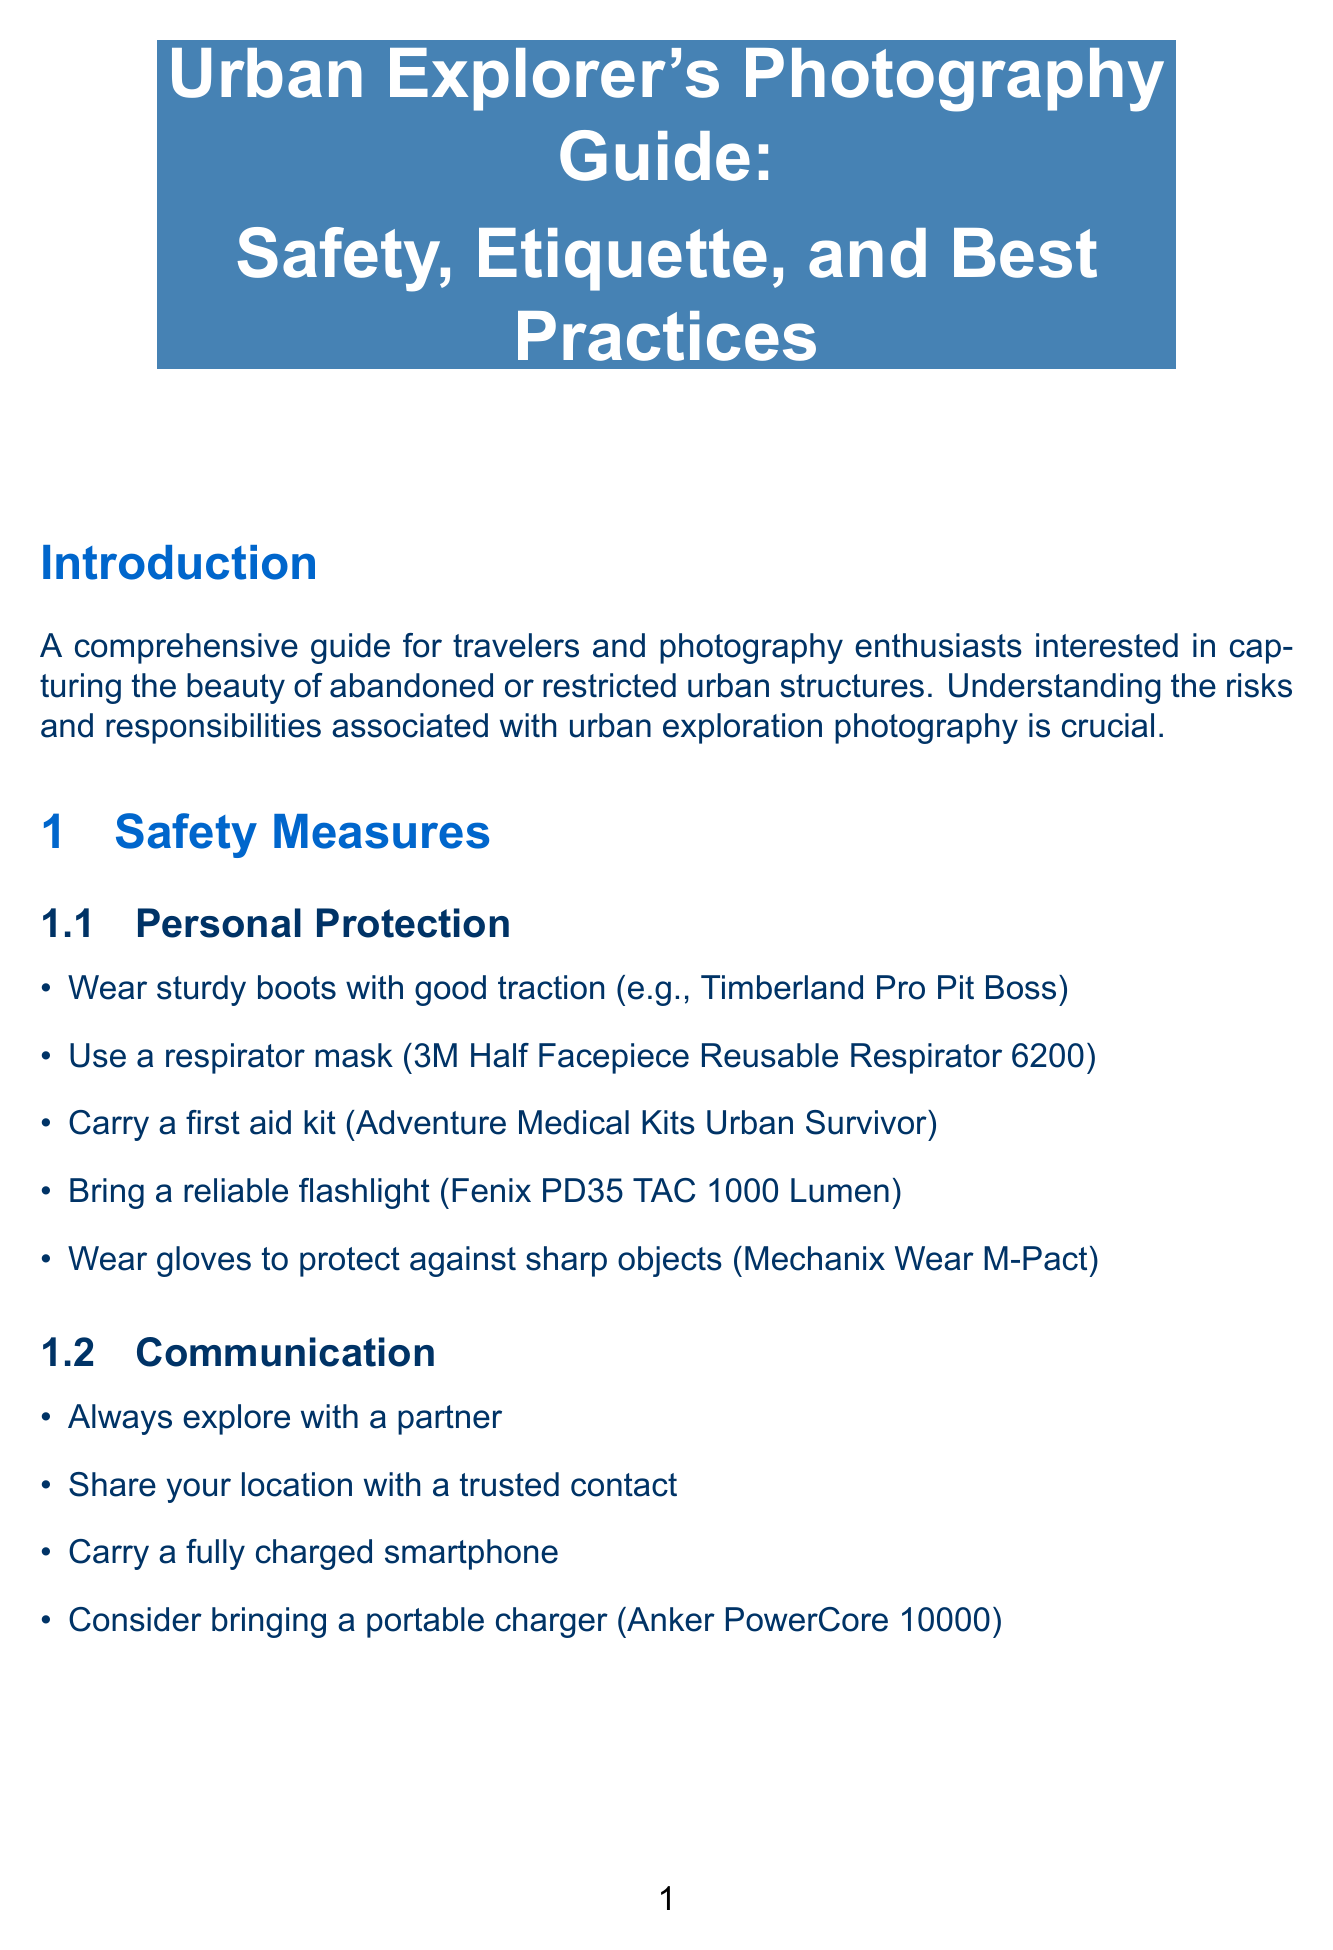What is the title of the guide? The title is explicitly stated in the document header, indicating the focus on urban exploration photography.
Answer: Urban Explorer's Photography Guide: Safety, Etiquette, and Best Practices What should you always carry when exploring? The document emphasizes the importance of communication and safety by listing essential items in safety measures.
Answer: A fully charged smartphone What type of camera is recommended? The photography best practices section suggests a specific type of camera for urban exploration.
Answer: Full-frame DSLR or mirrorless What is the purpose of using a tripod? The document explains the function of equipment, including tripods, under best practices for photography.
Answer: Stability for long exposures in low light conditions How many types of best practices are listed under photography? The photography best practices section contains a specific number of techniques for successful photography.
Answer: Four What is a key ethical consideration mentioned? The document discusses various ethical aspects regarding urban exploration photography.
Answer: Respect the history and integrity of the locations you photograph Which website is recommended for urban exploration resources? The resources section provides specific websites helpful for urban explorers.
Answer: Urban Exploration Resource (www.uer.ca) What should you do if confronted by security? The etiquette section provides advice on behavior when approached by authorities.
Answer: Be polite and cooperative What is one of the personal protection measures? Safety measures include specific items to enhance personal protection during exploration.
Answer: Wear sturdy boots with good traction 